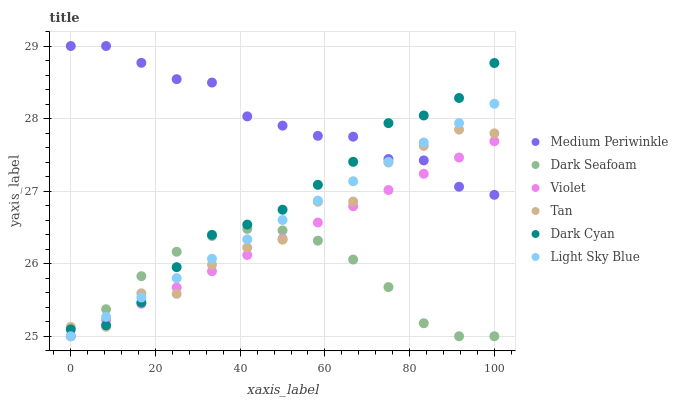Does Dark Seafoam have the minimum area under the curve?
Answer yes or no. Yes. Does Medium Periwinkle have the maximum area under the curve?
Answer yes or no. Yes. Does Light Sky Blue have the minimum area under the curve?
Answer yes or no. No. Does Light Sky Blue have the maximum area under the curve?
Answer yes or no. No. Is Violet the smoothest?
Answer yes or no. Yes. Is Tan the roughest?
Answer yes or no. Yes. Is Dark Seafoam the smoothest?
Answer yes or no. No. Is Dark Seafoam the roughest?
Answer yes or no. No. Does Dark Seafoam have the lowest value?
Answer yes or no. Yes. Does Dark Cyan have the lowest value?
Answer yes or no. No. Does Medium Periwinkle have the highest value?
Answer yes or no. Yes. Does Light Sky Blue have the highest value?
Answer yes or no. No. Is Dark Seafoam less than Medium Periwinkle?
Answer yes or no. Yes. Is Medium Periwinkle greater than Dark Seafoam?
Answer yes or no. Yes. Does Light Sky Blue intersect Violet?
Answer yes or no. Yes. Is Light Sky Blue less than Violet?
Answer yes or no. No. Is Light Sky Blue greater than Violet?
Answer yes or no. No. Does Dark Seafoam intersect Medium Periwinkle?
Answer yes or no. No. 